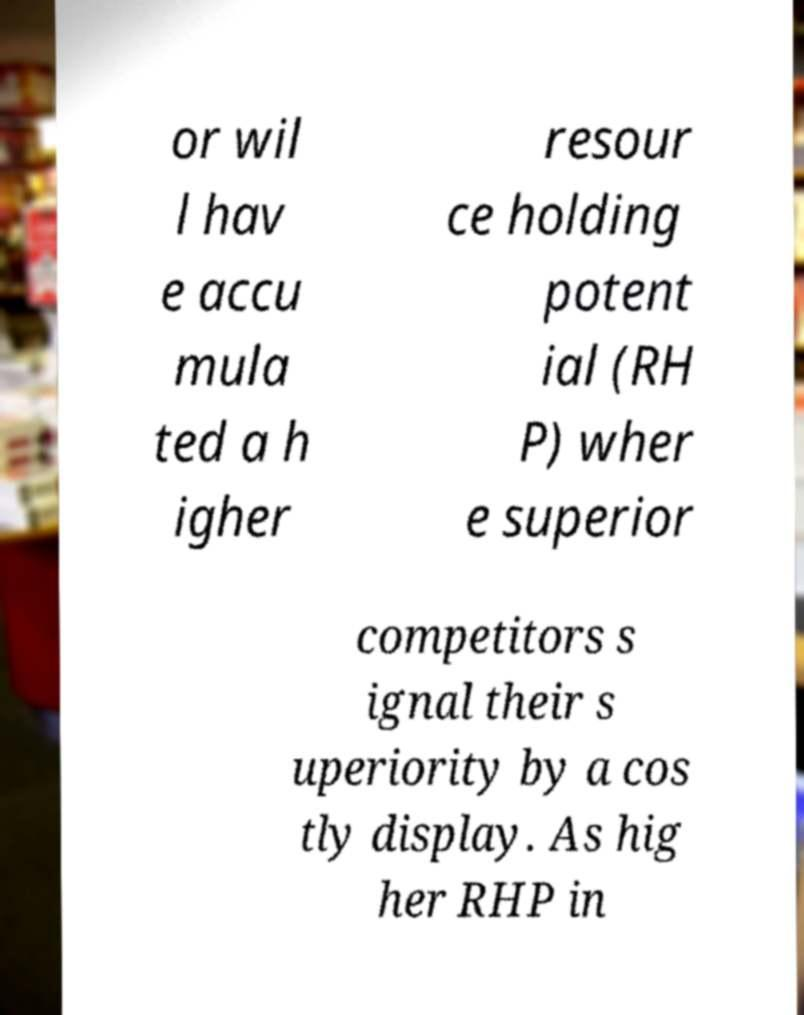Please read and relay the text visible in this image. What does it say? or wil l hav e accu mula ted a h igher resour ce holding potent ial (RH P) wher e superior competitors s ignal their s uperiority by a cos tly display. As hig her RHP in 